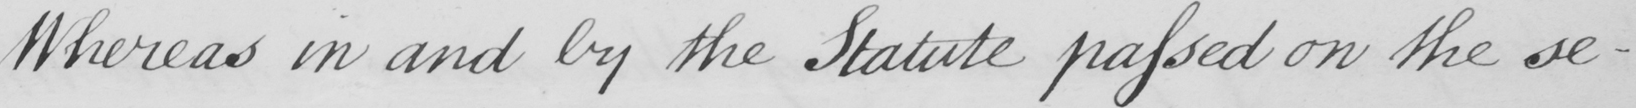What is written in this line of handwriting? Whereas in and by the Statute passed on the se- 